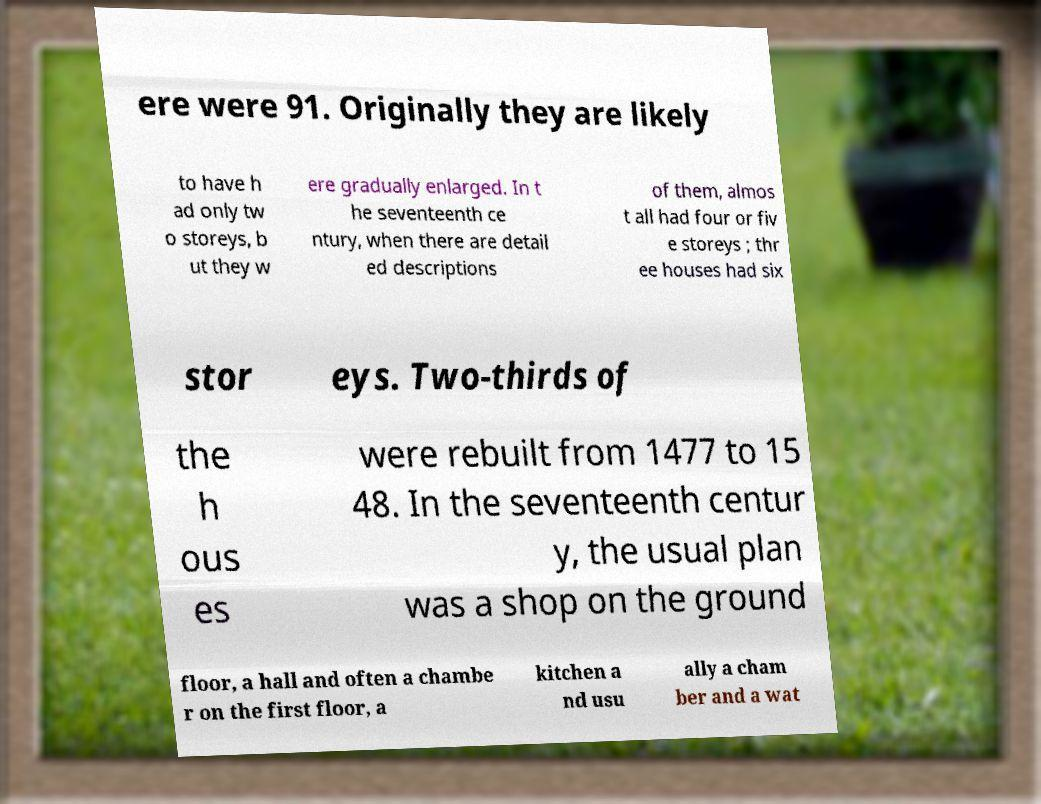Could you assist in decoding the text presented in this image and type it out clearly? ere were 91. Originally they are likely to have h ad only tw o storeys, b ut they w ere gradually enlarged. In t he seventeenth ce ntury, when there are detail ed descriptions of them, almos t all had four or fiv e storeys ; thr ee houses had six stor eys. Two-thirds of the h ous es were rebuilt from 1477 to 15 48. In the seventeenth centur y, the usual plan was a shop on the ground floor, a hall and often a chambe r on the first floor, a kitchen a nd usu ally a cham ber and a wat 